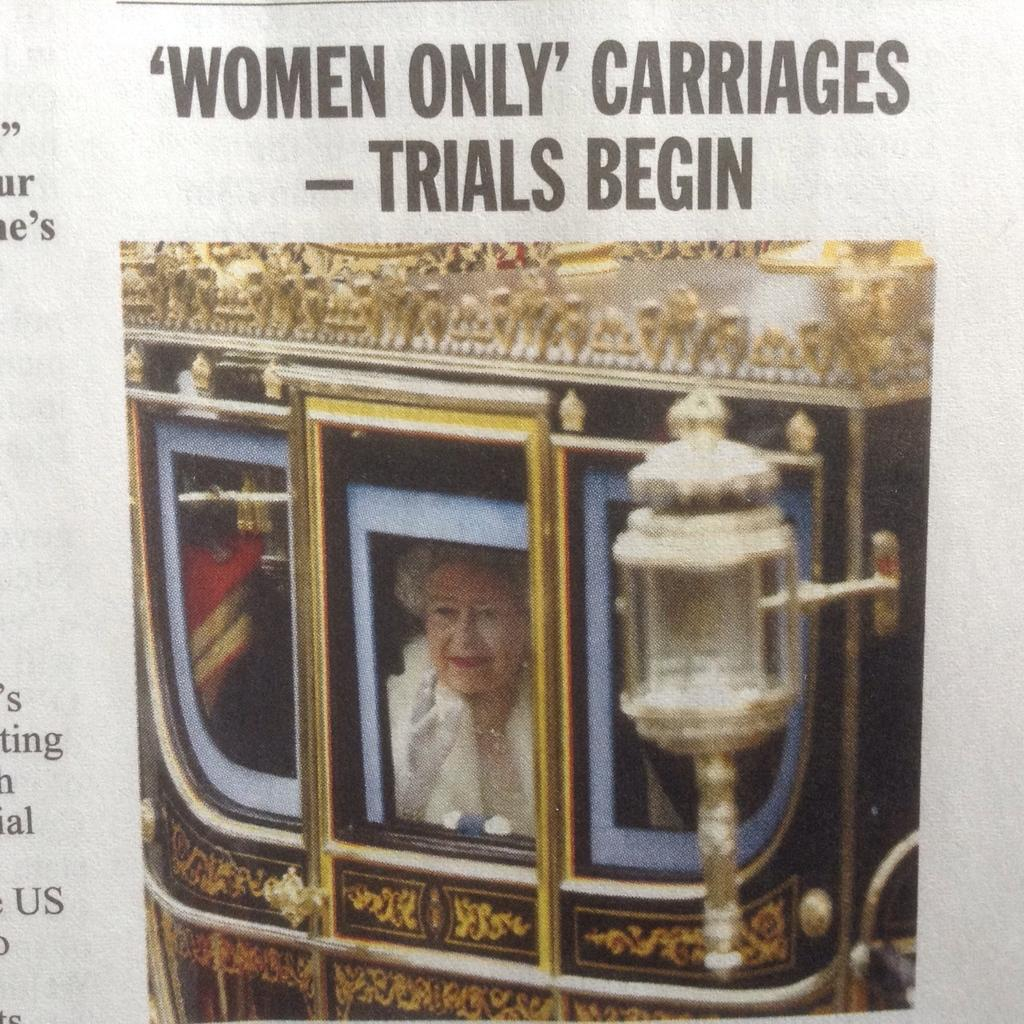What is depicted on the paper in the image? The paper in the image contains text and a picture. Can you describe the picture on the paper? The picture contains a woman sitting in a cart. What type of light source is present in the picture? There is an electric light in the picture. How many vegetables are being used to tie a knot in the image? There are no vegetables or knots present in the image. 